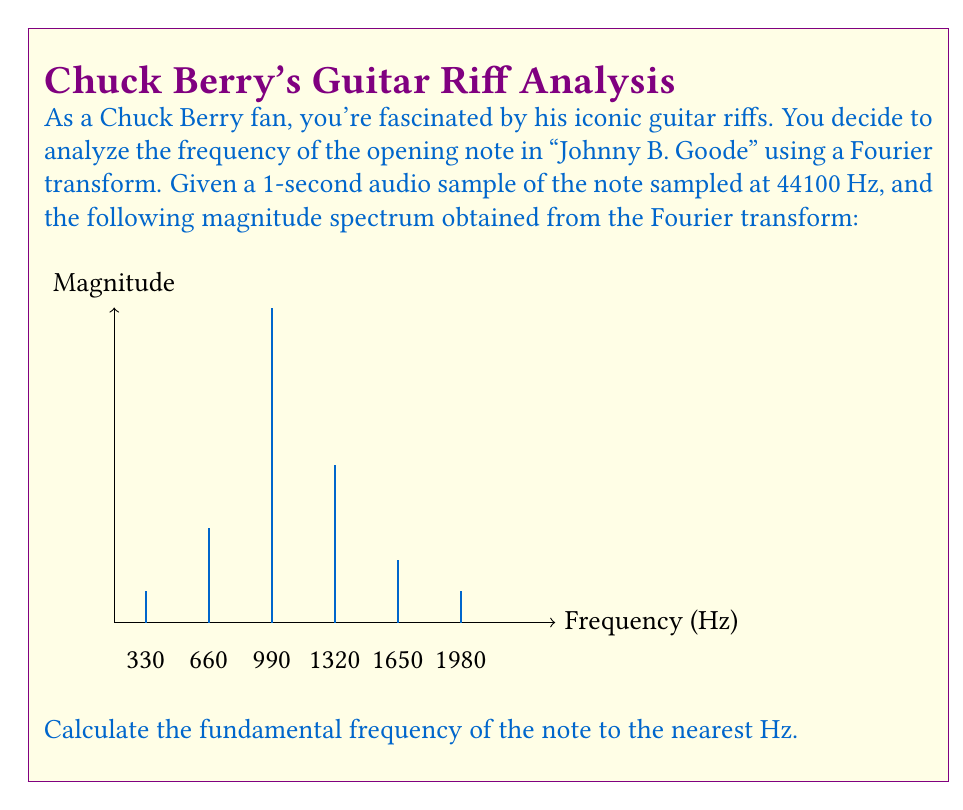Give your solution to this math problem. To find the fundamental frequency using the Fourier transform, we need to follow these steps:

1) In a Fourier transform of a musical note, the fundamental frequency is represented by the first significant peak in the magnitude spectrum.

2) Looking at the graph, we can see that the first and highest peak occurs at the fourth position from the left.

3) The x-axis shows the frequency in Hz, with intervals of 330 Hz between each peak.

4) To calculate the frequency of the fourth peak:
   $$ f = 330 \text{ Hz} \times (4-1) = 990 \text{ Hz} $$

5) This 990 Hz corresponds to the fundamental frequency of the note.

6) We can verify this by noting that the subsequent peaks occur at integer multiples of this frequency (harmonics):
   990 Hz (fundamental)
   1980 Hz (2nd harmonic)
   2970 Hz (3rd harmonic, not shown in the graph)

Therefore, the fundamental frequency of the opening note in "Johnny B. Goode" is 990 Hz.
Answer: 990 Hz 